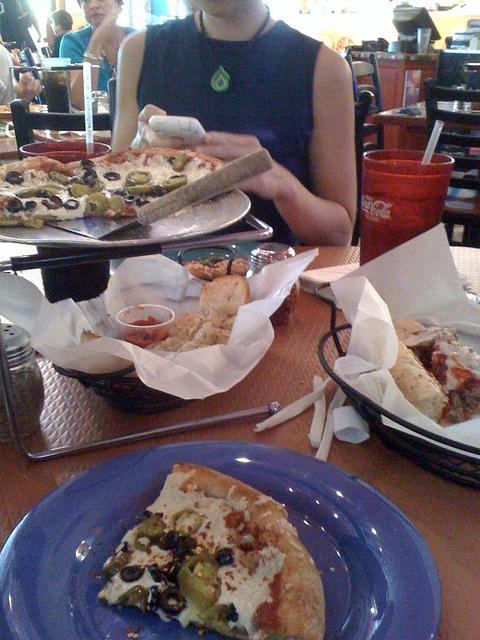What is in the thing with coke? straw 